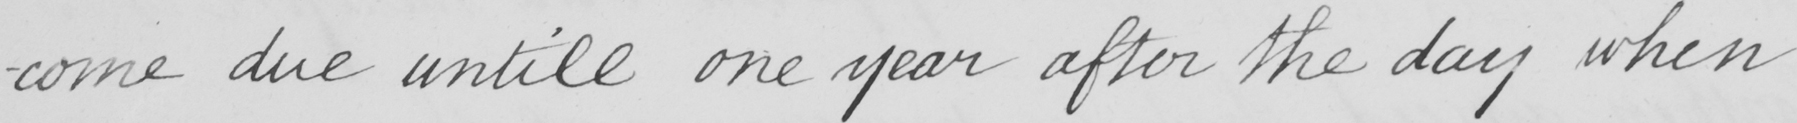Can you tell me what this handwritten text says? -come due untill one year after the day when 